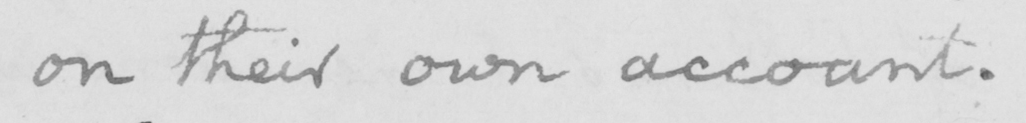Please transcribe the handwritten text in this image. on their own account. 